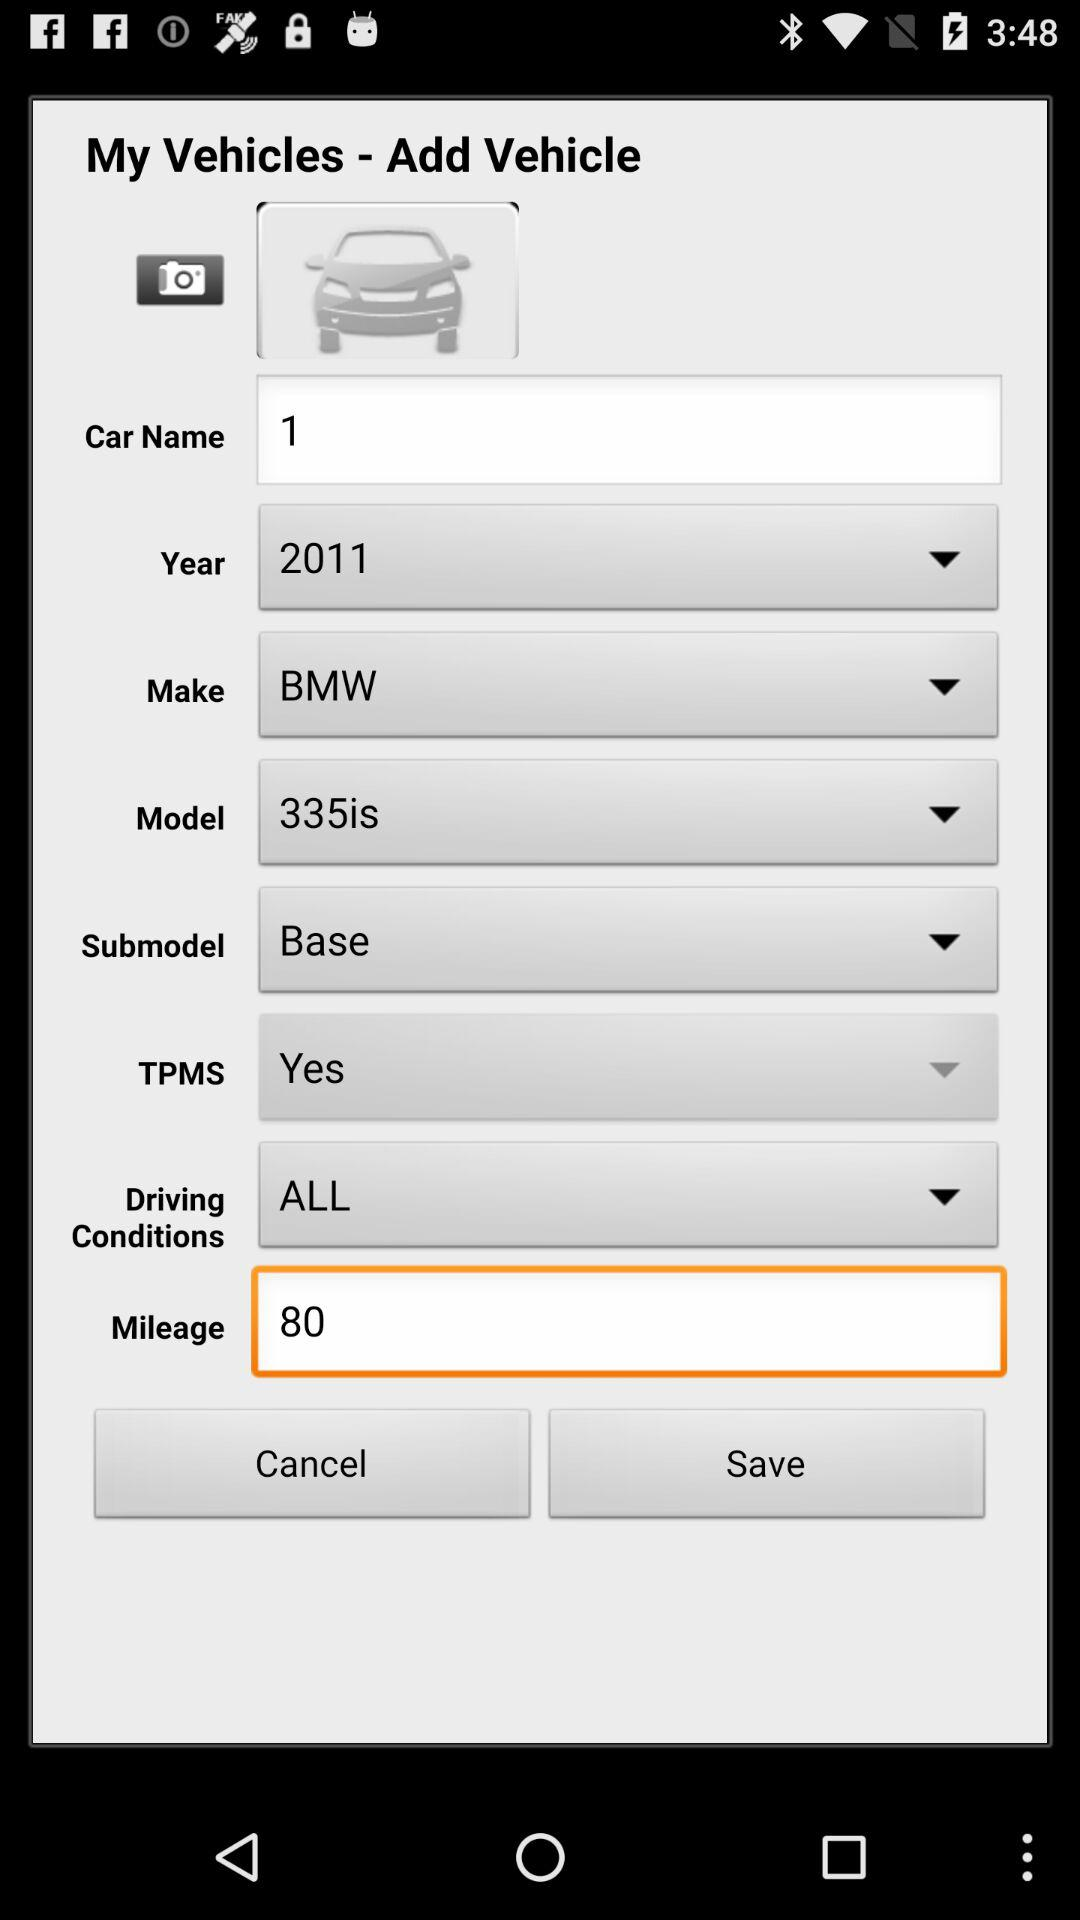How much is the mileage? The mileage is 80. 